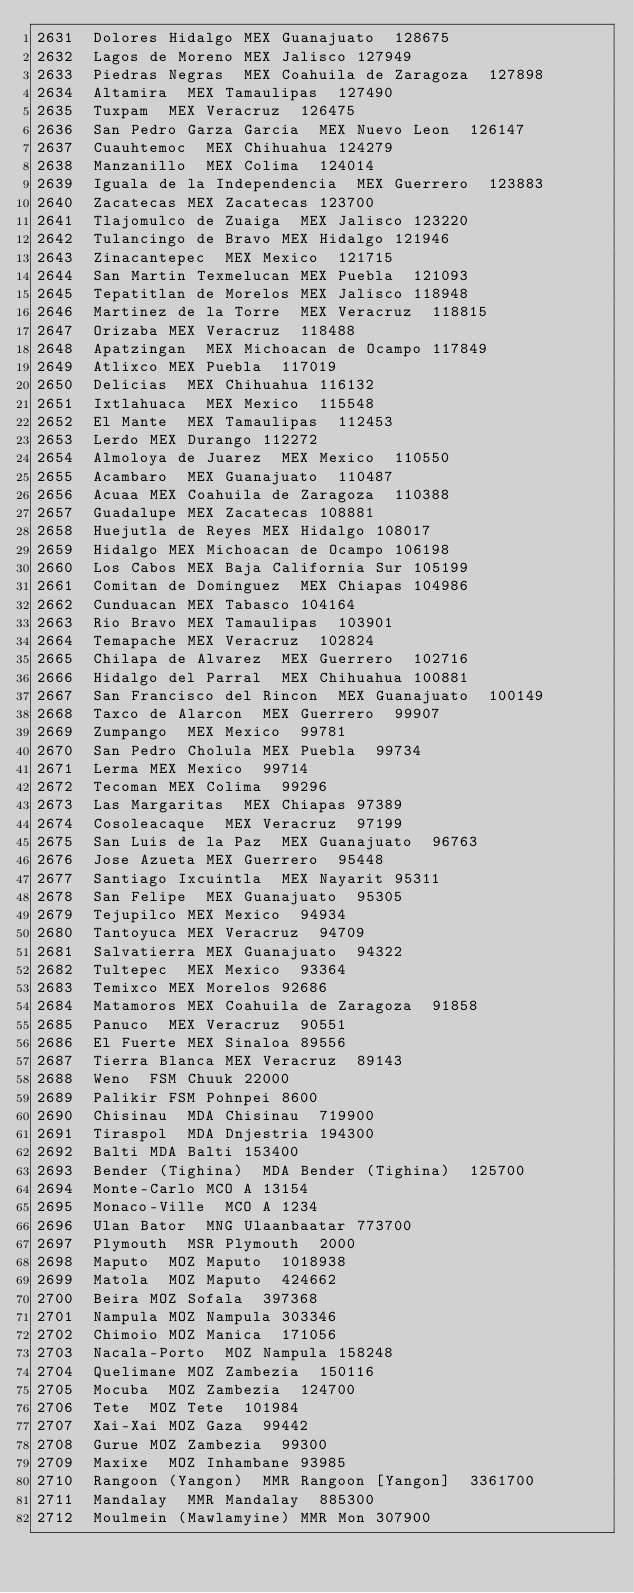<code> <loc_0><loc_0><loc_500><loc_500><_SQL_>2631	Dolores Hidalgo	MEX	Guanajuato	128675
2632	Lagos de Moreno	MEX	Jalisco	127949
2633	Piedras Negras	MEX	Coahuila de Zaragoza	127898
2634	Altamira	MEX	Tamaulipas	127490
2635	Tuxpam	MEX	Veracruz	126475
2636	San Pedro Garza Garcia	MEX	Nuevo Leon	126147
2637	Cuauhtemoc	MEX	Chihuahua	124279
2638	Manzanillo	MEX	Colima	124014
2639	Iguala de la Independencia	MEX	Guerrero	123883
2640	Zacatecas	MEX	Zacatecas	123700
2641	Tlajomulco de Zuaiga	MEX	Jalisco	123220
2642	Tulancingo de Bravo	MEX	Hidalgo	121946
2643	Zinacantepec	MEX	Mexico	121715
2644	San Martin Texmelucan	MEX	Puebla	121093
2645	Tepatitlan de Morelos	MEX	Jalisco	118948
2646	Martinez de la Torre	MEX	Veracruz	118815
2647	Orizaba	MEX	Veracruz	118488
2648	Apatzingan	MEX	Michoacan de Ocampo	117849
2649	Atlixco	MEX	Puebla	117019
2650	Delicias	MEX	Chihuahua	116132
2651	Ixtlahuaca	MEX	Mexico	115548
2652	El Mante	MEX	Tamaulipas	112453
2653	Lerdo	MEX	Durango	112272
2654	Almoloya de Juarez	MEX	Mexico	110550
2655	Acambaro	MEX	Guanajuato	110487
2656	Acuaa	MEX	Coahuila de Zaragoza	110388
2657	Guadalupe	MEX	Zacatecas	108881
2658	Huejutla de Reyes	MEX	Hidalgo	108017
2659	Hidalgo	MEX	Michoacan de Ocampo	106198
2660	Los Cabos	MEX	Baja California Sur	105199
2661	Comitan de Dominguez	MEX	Chiapas	104986
2662	Cunduacan	MEX	Tabasco	104164
2663	Rio Bravo	MEX	Tamaulipas	103901
2664	Temapache	MEX	Veracruz	102824
2665	Chilapa de Alvarez	MEX	Guerrero	102716
2666	Hidalgo del Parral	MEX	Chihuahua	100881
2667	San Francisco del Rincon	MEX	Guanajuato	100149
2668	Taxco de Alarcon	MEX	Guerrero	99907
2669	Zumpango	MEX	Mexico	99781
2670	San Pedro Cholula	MEX	Puebla	99734
2671	Lerma	MEX	Mexico	99714
2672	Tecoman	MEX	Colima	99296
2673	Las Margaritas	MEX	Chiapas	97389
2674	Cosoleacaque	MEX	Veracruz	97199
2675	San Luis de la Paz	MEX	Guanajuato	96763
2676	Jose Azueta	MEX	Guerrero	95448
2677	Santiago Ixcuintla	MEX	Nayarit	95311
2678	San Felipe	MEX	Guanajuato	95305
2679	Tejupilco	MEX	Mexico	94934
2680	Tantoyuca	MEX	Veracruz	94709
2681	Salvatierra	MEX	Guanajuato	94322
2682	Tultepec	MEX	Mexico	93364
2683	Temixco	MEX	Morelos	92686
2684	Matamoros	MEX	Coahuila de Zaragoza	91858
2685	Panuco	MEX	Veracruz	90551
2686	El Fuerte	MEX	Sinaloa	89556
2687	Tierra Blanca	MEX	Veracruz	89143
2688	Weno	FSM	Chuuk	22000
2689	Palikir	FSM	Pohnpei	8600
2690	Chisinau	MDA	Chisinau	719900
2691	Tiraspol	MDA	Dnjestria	194300
2692	Balti	MDA	Balti	153400
2693	Bender (Tighina)	MDA	Bender (Tighina)	125700
2694	Monte-Carlo	MCO	A	13154
2695	Monaco-Ville	MCO	A	1234
2696	Ulan Bator	MNG	Ulaanbaatar	773700
2697	Plymouth	MSR	Plymouth	2000
2698	Maputo	MOZ	Maputo	1018938
2699	Matola	MOZ	Maputo	424662
2700	Beira	MOZ	Sofala	397368
2701	Nampula	MOZ	Nampula	303346
2702	Chimoio	MOZ	Manica	171056
2703	Nacala-Porto	MOZ	Nampula	158248
2704	Quelimane	MOZ	Zambezia	150116
2705	Mocuba	MOZ	Zambezia	124700
2706	Tete	MOZ	Tete	101984
2707	Xai-Xai	MOZ	Gaza	99442
2708	Gurue	MOZ	Zambezia	99300
2709	Maxixe	MOZ	Inhambane	93985
2710	Rangoon (Yangon)	MMR	Rangoon [Yangon]	3361700
2711	Mandalay	MMR	Mandalay	885300
2712	Moulmein (Mawlamyine)	MMR	Mon	307900</code> 